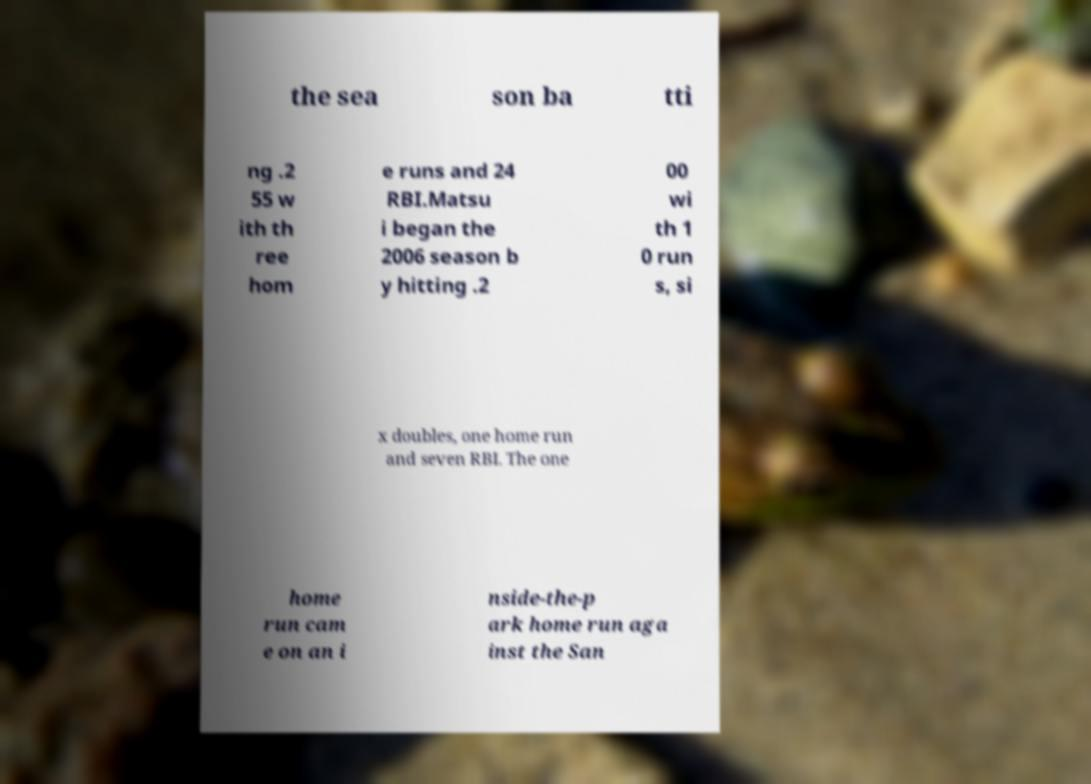Can you accurately transcribe the text from the provided image for me? the sea son ba tti ng .2 55 w ith th ree hom e runs and 24 RBI.Matsu i began the 2006 season b y hitting .2 00 wi th 1 0 run s, si x doubles, one home run and seven RBI. The one home run cam e on an i nside-the-p ark home run aga inst the San 